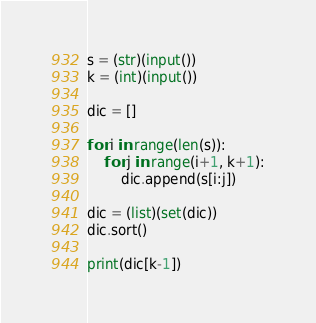Convert code to text. <code><loc_0><loc_0><loc_500><loc_500><_Python_>s = (str)(input())
k = (int)(input())

dic = []

for i in range(len(s)):
    for j in range(i+1, k+1):
        dic.append(s[i:j])

dic = (list)(set(dic))
dic.sort()

print(dic[k-1])
</code> 